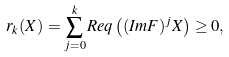Convert formula to latex. <formula><loc_0><loc_0><loc_500><loc_500>r _ { k } ( X ) = \sum _ { j = 0 } ^ { k } R e q \left ( ( I m F ) ^ { j } X \right ) \geq 0 ,</formula> 